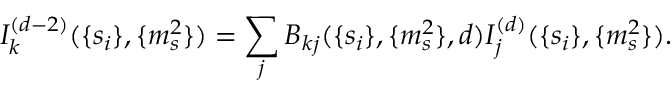<formula> <loc_0><loc_0><loc_500><loc_500>I _ { k } ^ { ( d - 2 ) } ( \{ s _ { i } \} , \{ m _ { s } ^ { 2 } \} ) = \sum _ { j } B _ { k j } ( \{ s _ { i } \} , \{ m _ { s } ^ { 2 } \} , d ) I _ { j } ^ { ( d ) } ( \{ s _ { i } \} , \{ m _ { s } ^ { 2 } \} ) .</formula> 